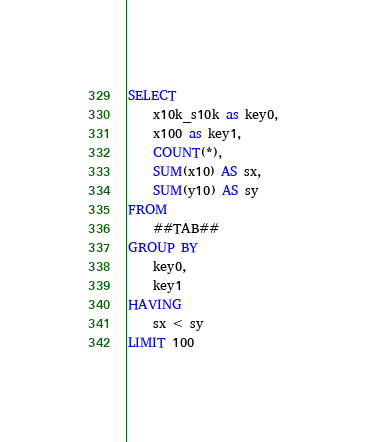Convert code to text. <code><loc_0><loc_0><loc_500><loc_500><_SQL_>SELECT
    x10k_s10k as key0,
    x100 as key1,
    COUNT(*),
    SUM(x10) AS sx,
    SUM(y10) AS sy
FROM
    ##TAB##
GROUP BY 
    key0,
    key1
HAVING
    sx < sy
LIMIT 100</code> 